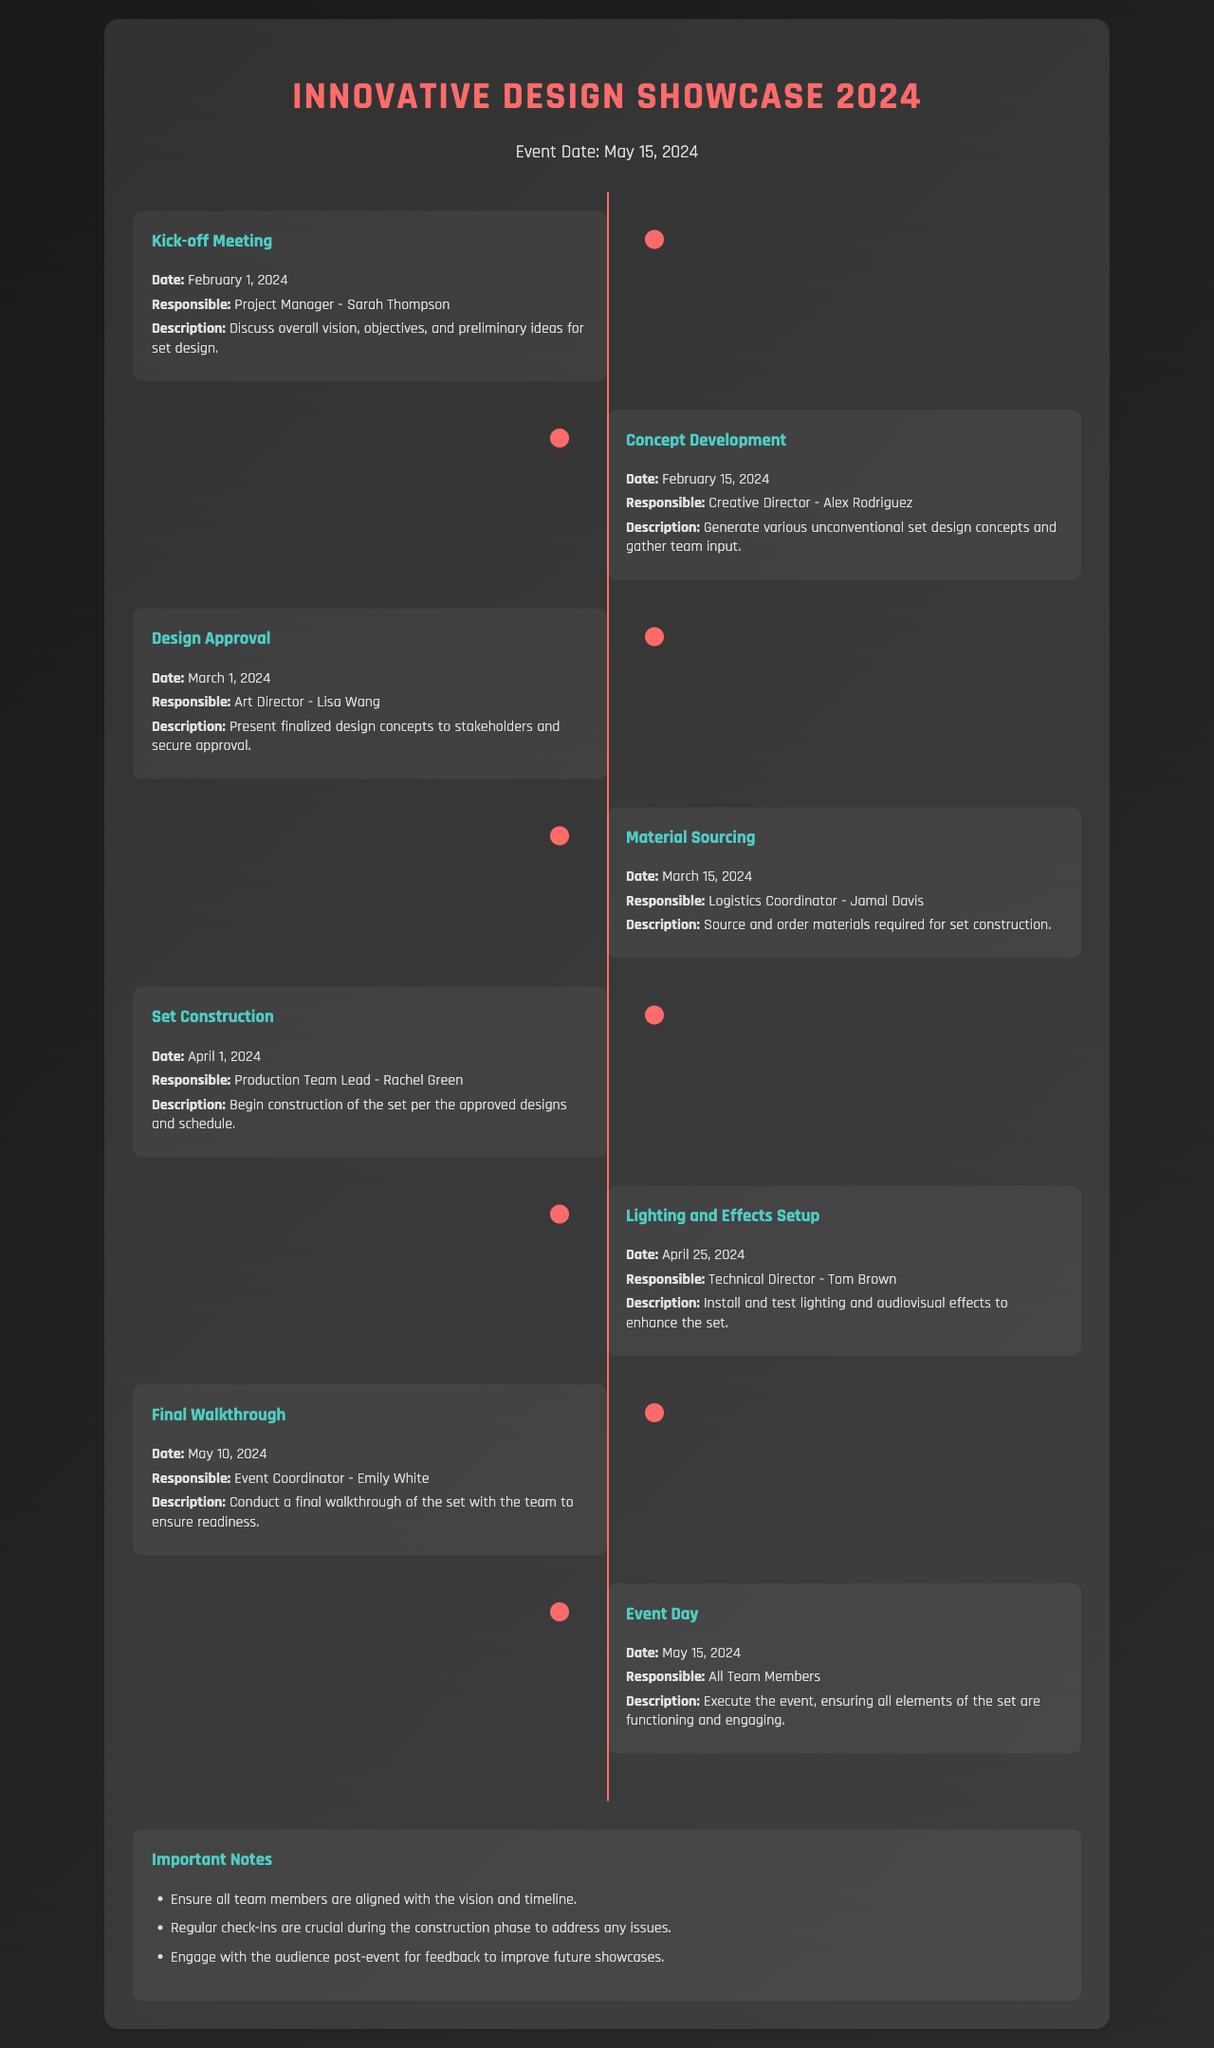What is the event date? The event date is explicitly mentioned in the document, which is May 15, 2024.
Answer: May 15, 2024 Who is responsible for the Kick-off Meeting? The document states that Sarah Thompson is the Project Manager responsible for the Kick-off Meeting.
Answer: Sarah Thompson When does the Set Construction start? The timeline indicates that Set Construction starts on April 1, 2024.
Answer: April 1, 2024 What is the last milestone before the event day? The last milestone mentioned before the event day is the Final Walkthrough scheduled for May 10, 2024.
Answer: Final Walkthrough Who is responsible for the Lighting and Effects Setup? According to the timeline, Tom Brown is the Technical Director responsible for the Lighting and Effects Setup.
Answer: Tom Brown What are team members advised to do during the construction phase? The document highlights the importance of regular check-ins to address any issues during the construction phase.
Answer: Regular check-ins How many days are there between the Design Approval and Material Sourcing? The timeline indicates there is a 14-day gap between the Design Approval (March 1, 2024) and Material Sourcing (March 15, 2024).
Answer: 14 days What is mentioned about audience engagement post-event? The notes section of the document mentions that engaging with the audience post-event for feedback is crucial.
Answer: Feedback What is the main goal for the event day? The document states that the main goal during the event day is to execute the event and ensure all elements of the set are functioning and engaging.
Answer: Execute the event 